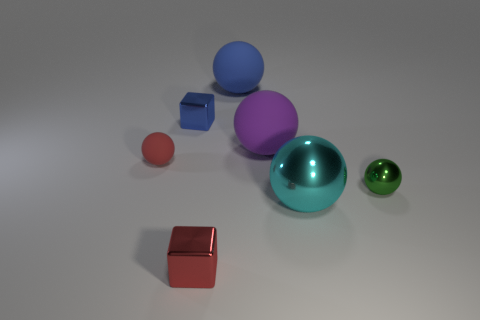Subtract all green spheres. How many spheres are left? 4 Add 1 blue matte balls. How many objects exist? 8 Subtract all red cubes. How many cubes are left? 1 Subtract all yellow spheres. Subtract all blue cylinders. How many spheres are left? 5 Subtract all spheres. How many objects are left? 2 Subtract all gray metallic balls. Subtract all small red metallic blocks. How many objects are left? 6 Add 7 big balls. How many big balls are left? 10 Add 3 tiny green shiny objects. How many tiny green shiny objects exist? 4 Subtract 0 green cylinders. How many objects are left? 7 